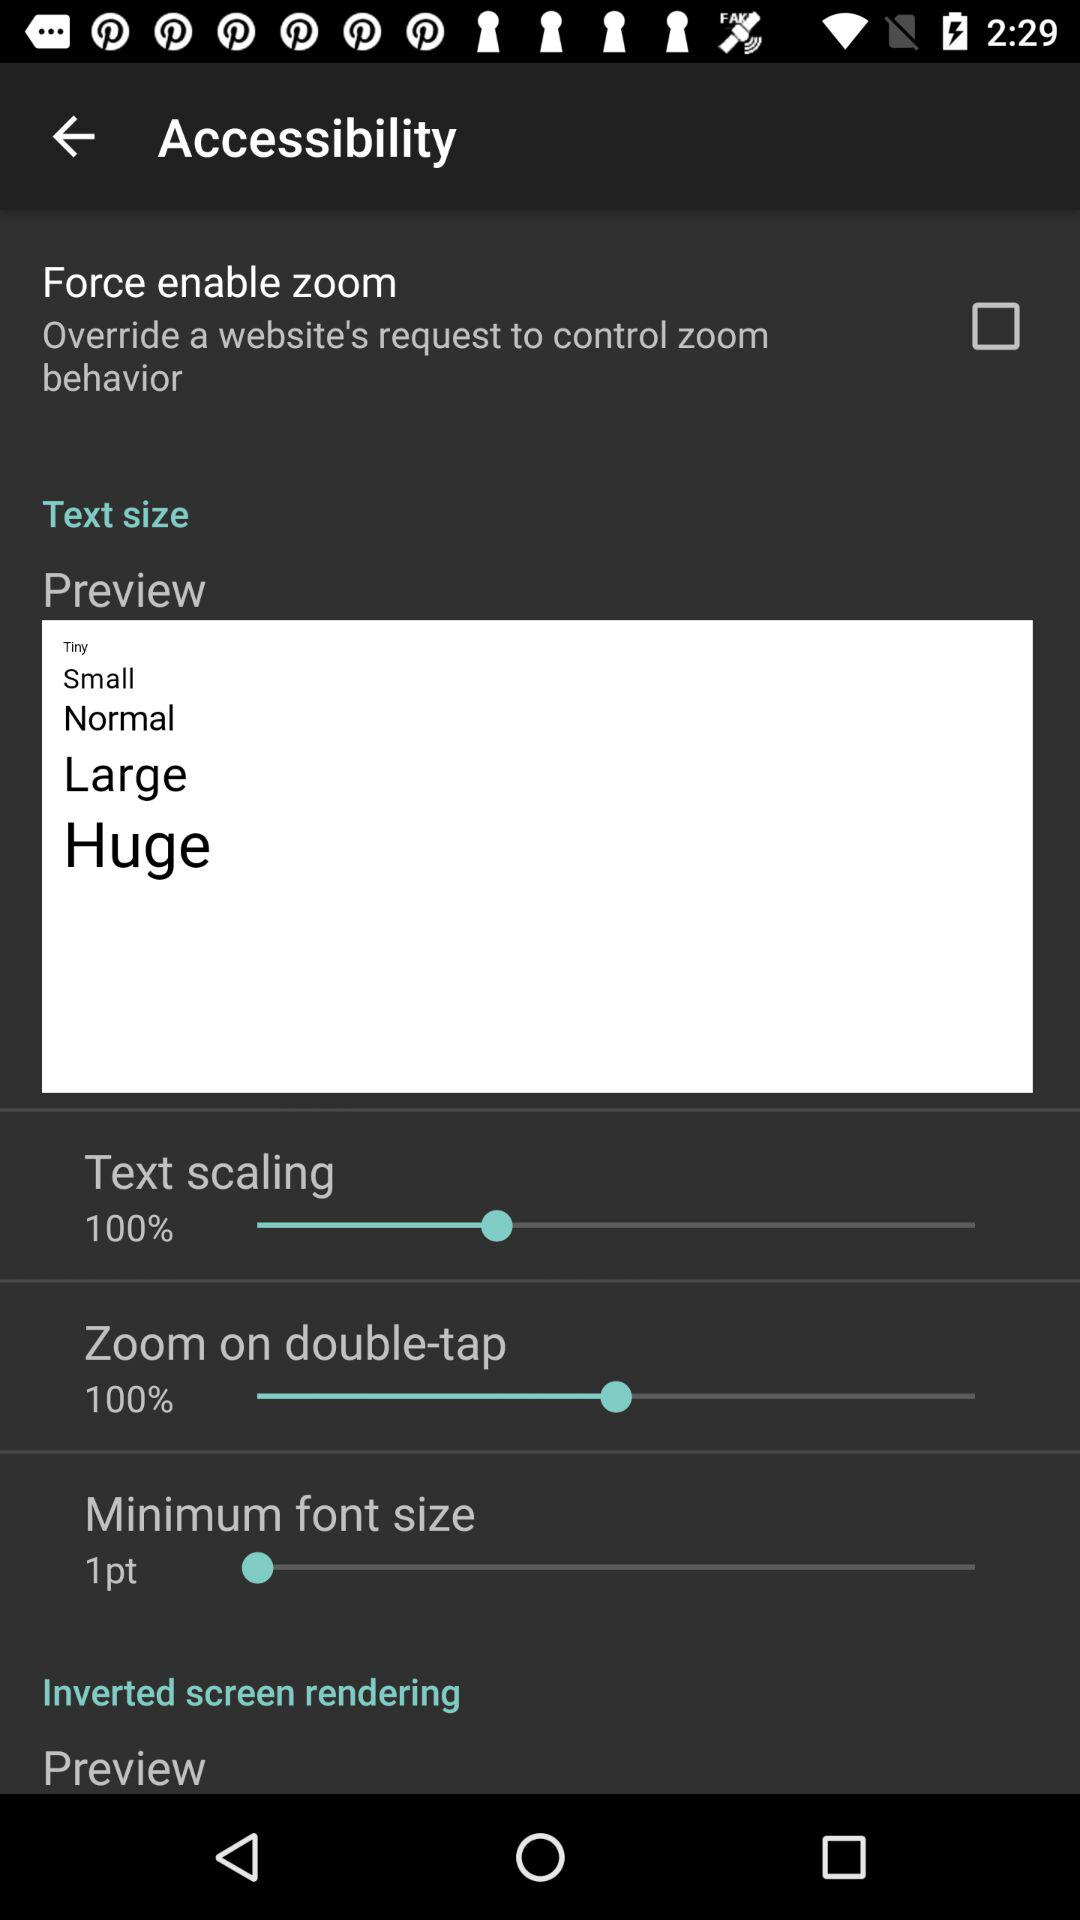What's the percentage of text scaling? The percentage is 100. 